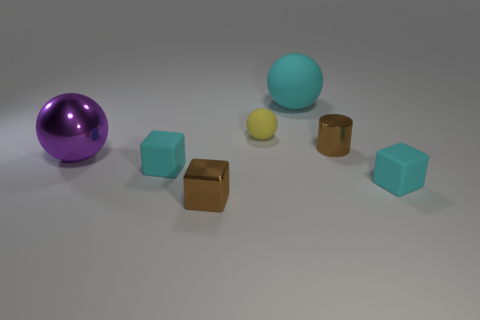What number of shiny cylinders are the same color as the metallic block?
Provide a succinct answer. 1. The matte ball that is the same size as the cylinder is what color?
Offer a very short reply. Yellow. Is the size of the cyan matte sphere the same as the metallic ball?
Keep it short and to the point. Yes. How many objects are either balls behind the large metal ball or tiny cyan rubber things that are on the right side of the small yellow matte sphere?
Offer a very short reply. 3. There is a small yellow object that is the same shape as the big metal object; what material is it?
Ensure brevity in your answer.  Rubber. What number of objects are either things that are on the right side of the brown shiny cube or tiny yellow things?
Offer a very short reply. 4. What shape is the yellow thing that is the same material as the large cyan sphere?
Offer a terse response. Sphere. What number of other metal things are the same shape as the large purple thing?
Keep it short and to the point. 0. What material is the large purple thing?
Give a very brief answer. Metal. There is a big metallic ball; does it have the same color as the small metallic thing that is on the left side of the big cyan matte object?
Give a very brief answer. No. 